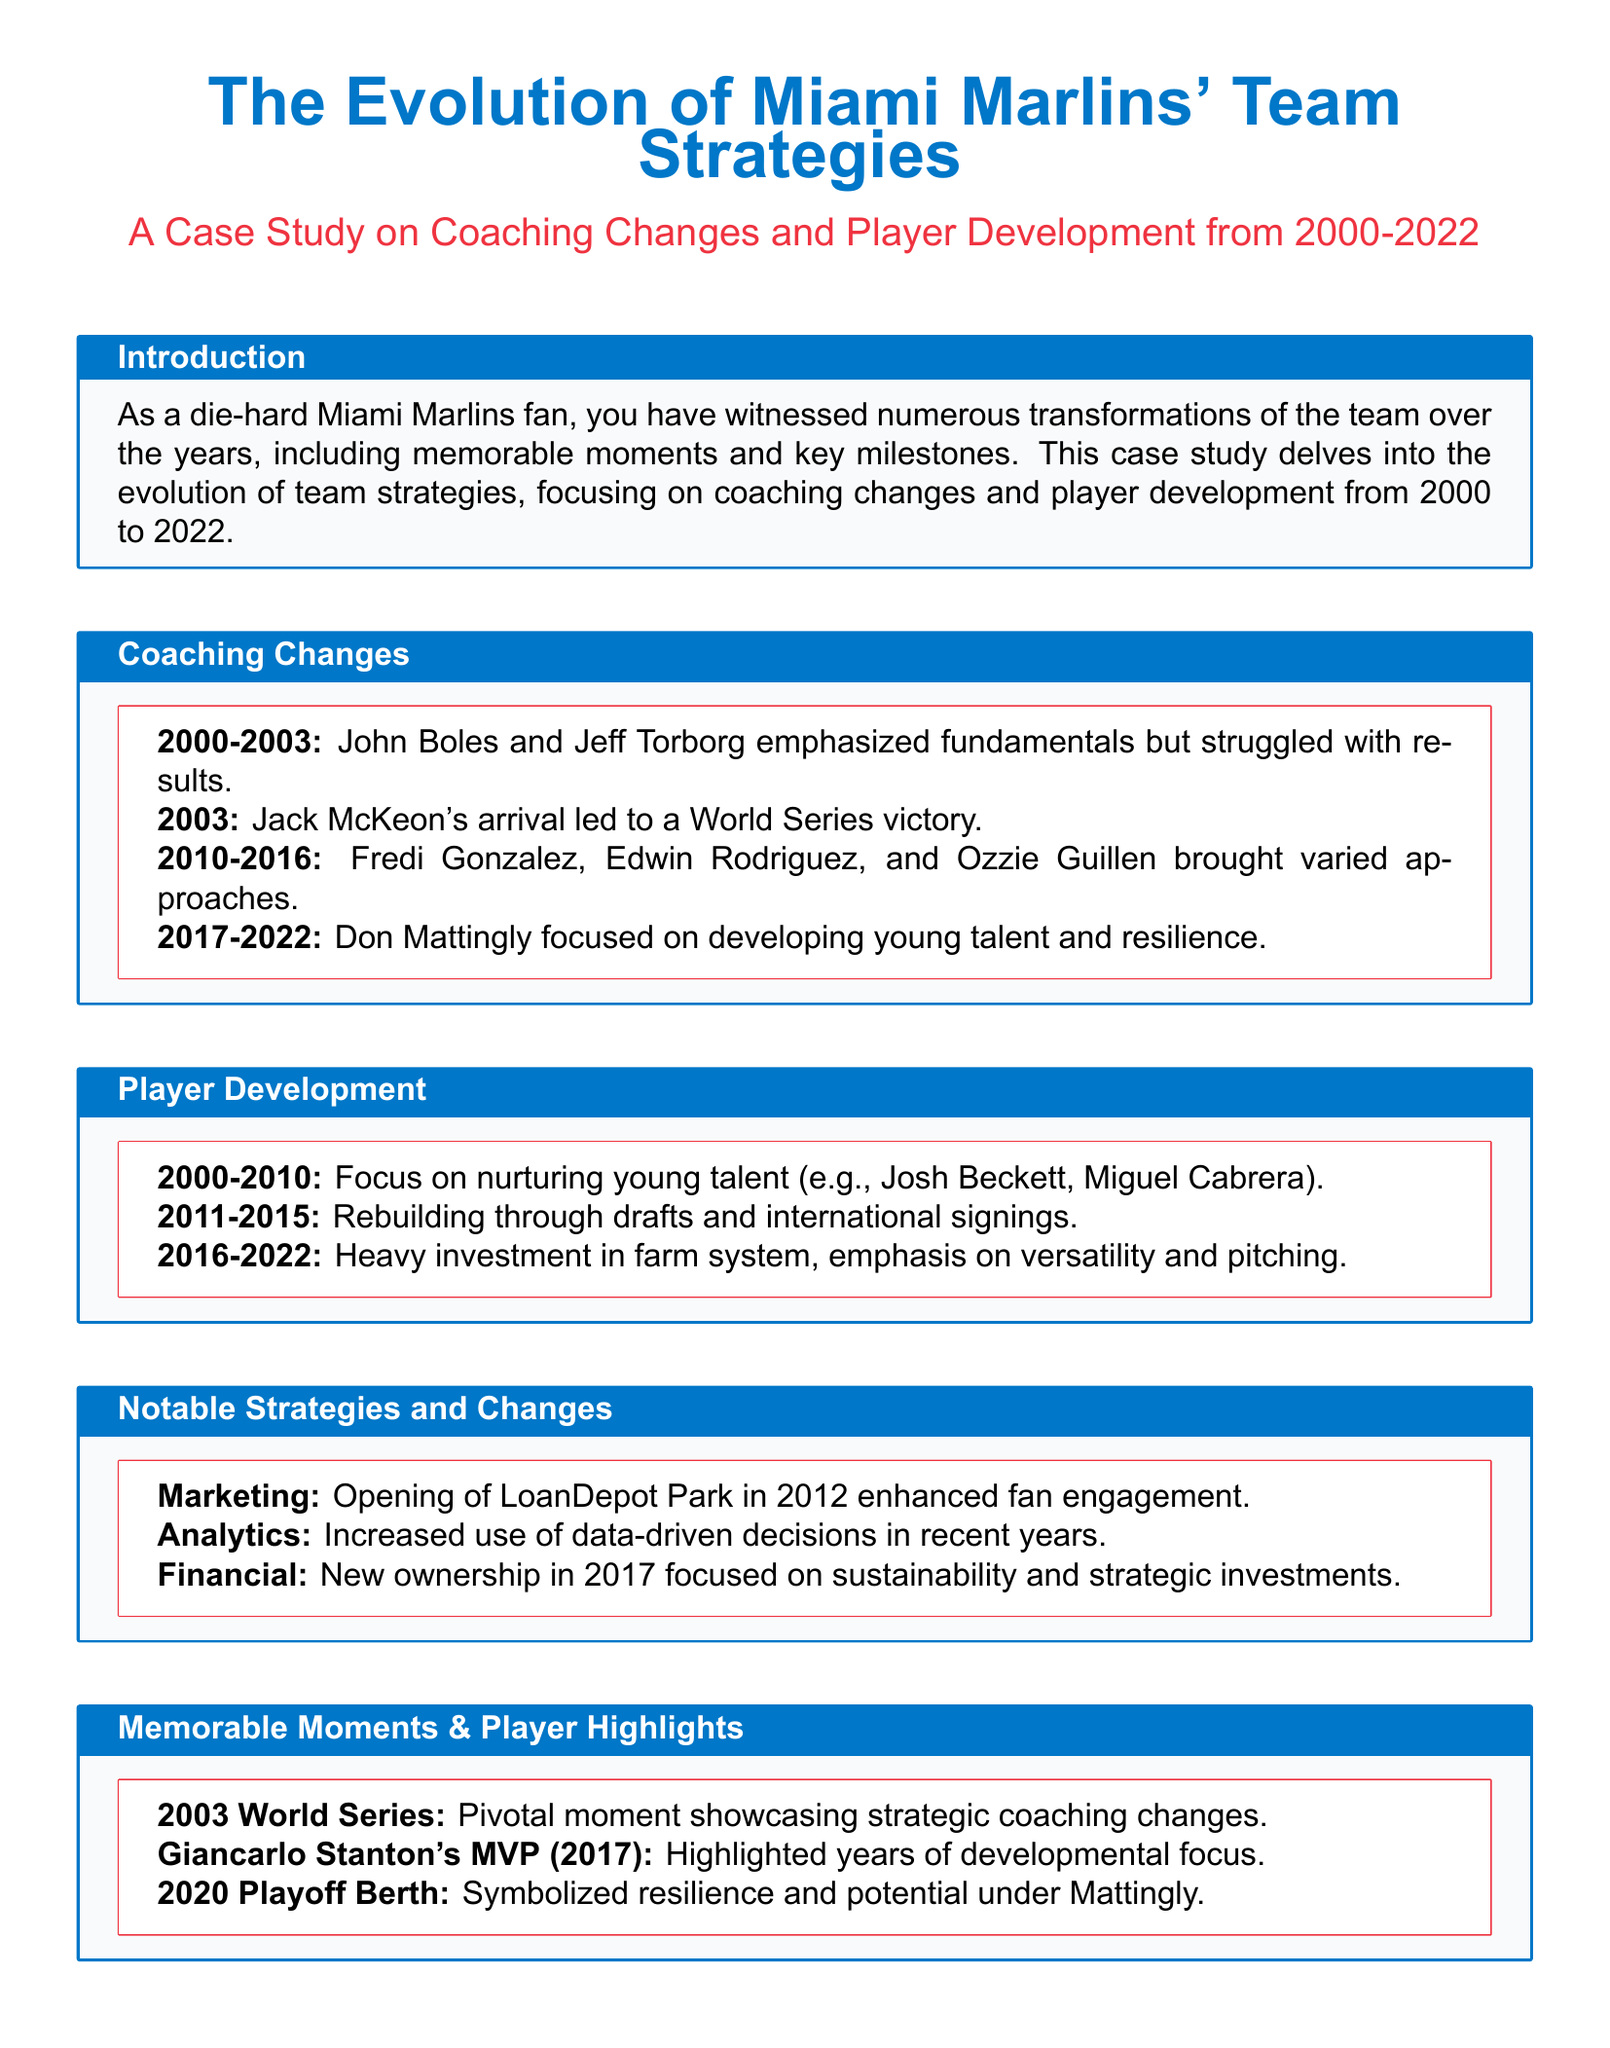What year did Jack McKeon arrive as manager? The document states that Jack McKeon arrived in 2003, leading the team to a World Series victory.
Answer: 2003 Who was the MVP in 2017? The document highlights Giancarlo Stanton as the MVP in 2017, showcasing years of developmental focus.
Answer: Giancarlo Stanton Which key milestone is associated with 2012? According to the document, the opening of LoanDepot Park in 2012 is a key milestone related to marketing and fan engagement.
Answer: LoanDepot Park What was the focus of player development from 2016-2022? The document indicates that from 2016 to 2022, the focus was on heavy investment in the farm system and emphasis on versatility and pitching.
Answer: Versatility and pitching What coaching change occurred in 2017? The document notes that new ownership focused on sustainability and strategic investments in 2017, impacting team strategies.
Answer: New ownership Which year did the Marlins achieve a playoff berth? The document mentions that the Miami Marlins achieved a playoff berth in 2020, symbolizing resilience under Don Mattingly.
Answer: 2020 What were the main approaches of coaches from 2010 to 2016? The document describes that Fredi Gonzalez, Edwin Rodriguez, and Ozzie Guillen brought varied approaches during their coaching tenures from 2010 to 2016.
Answer: Varied approaches What significant moment occurred in 2003? The pivotal moment in 2003 mentioned in the document was the team's victory in the World Series, showcasing strategic coaching changes.
Answer: World Series victory 